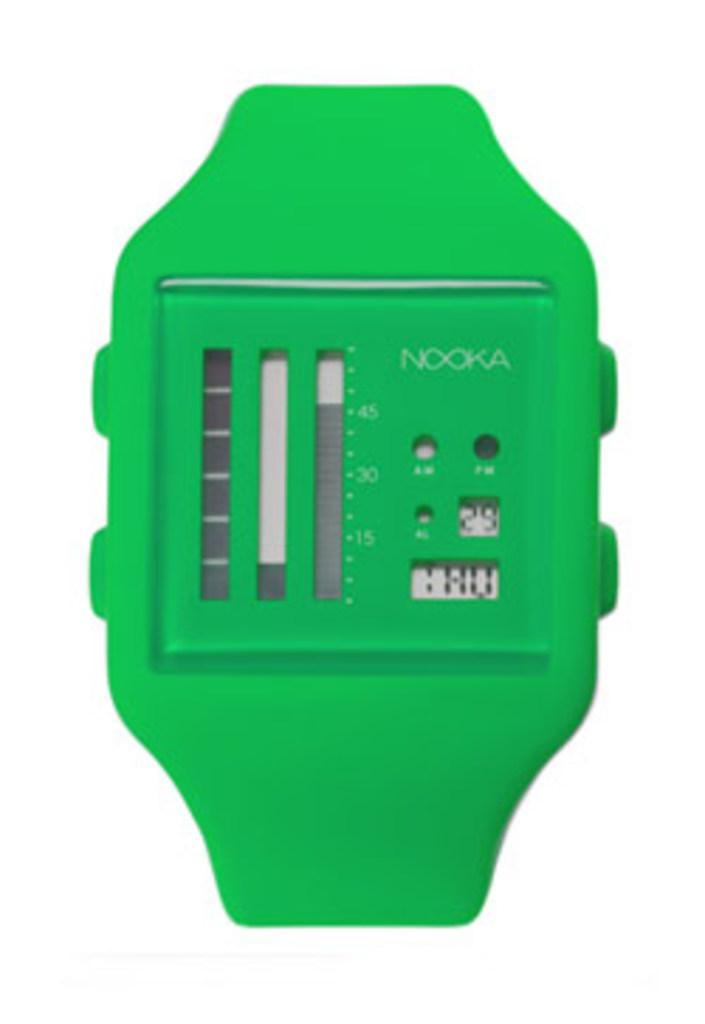<image>
Share a concise interpretation of the image provided. A green device which has the number 30 faintly visible. 